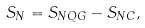<formula> <loc_0><loc_0><loc_500><loc_500>S _ { N } = S _ { N Q G } - S _ { N C } ,</formula> 